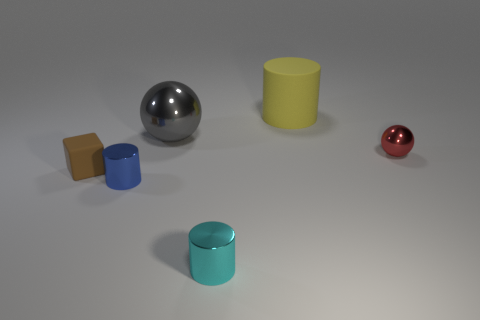There is a matte object behind the small red metal thing; is its size the same as the thing that is on the right side of the big yellow matte cylinder?
Give a very brief answer. No. Are there any large things made of the same material as the cyan cylinder?
Ensure brevity in your answer.  Yes. Are there any large yellow things in front of the sphere behind the tiny shiny object that is right of the yellow object?
Keep it short and to the point. No. Are there any matte things to the left of the large yellow thing?
Provide a succinct answer. Yes. What number of big yellow objects are in front of the matte thing on the right side of the brown thing?
Give a very brief answer. 0. There is a cyan cylinder; is it the same size as the rubber thing that is on the left side of the cyan object?
Your answer should be very brief. Yes. There is a gray ball that is the same material as the blue cylinder; what is its size?
Provide a short and direct response. Large. Is the material of the large cylinder the same as the small block?
Give a very brief answer. Yes. What is the color of the metal thing that is right of the large object that is right of the tiny thing in front of the tiny blue metallic object?
Your response must be concise. Red. There is a tiny cyan object; what shape is it?
Offer a very short reply. Cylinder. 